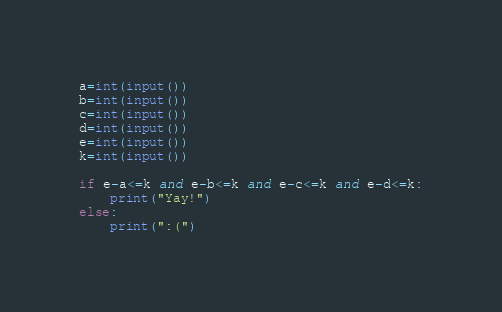Convert code to text. <code><loc_0><loc_0><loc_500><loc_500><_Python_>a=int(input())
b=int(input())
c=int(input())
d=int(input())
e=int(input())
k=int(input())

if e-a<=k and e-b<=k and e-c<=k and e-d<=k:
    print("Yay!")
else:
    print(":(")

</code> 